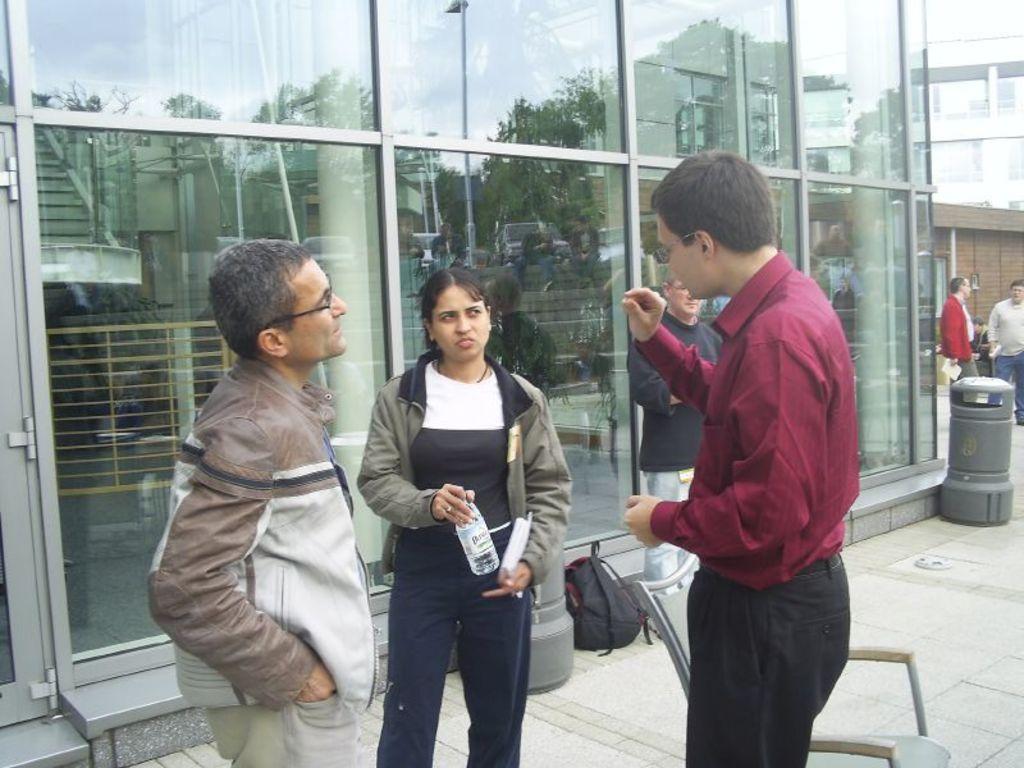Describe this image in one or two sentences. This picture describes about group of people, few people wore spectacles, in the middle of the image we can see a woman, she is holding a bottle and a book, beside her we can see a chair and a bag, in the background we can see glasses and few buildings. 